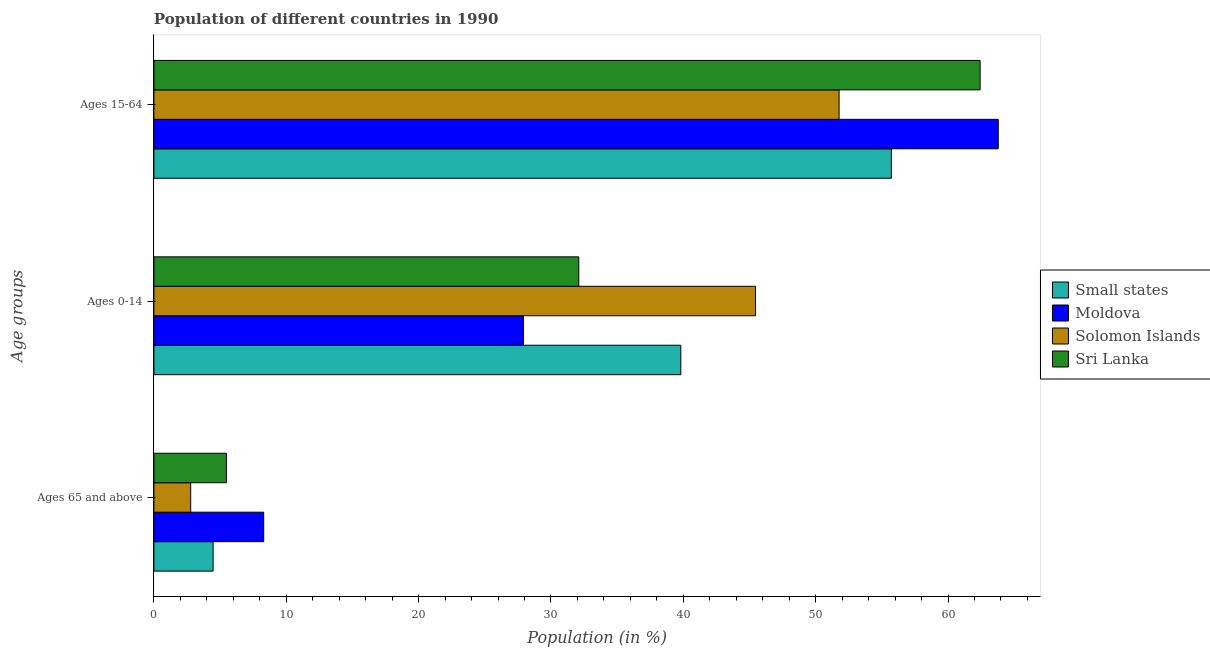What is the label of the 1st group of bars from the top?
Ensure brevity in your answer.  Ages 15-64. What is the percentage of population within the age-group of 65 and above in Solomon Islands?
Give a very brief answer. 2.78. Across all countries, what is the maximum percentage of population within the age-group 0-14?
Give a very brief answer. 45.45. Across all countries, what is the minimum percentage of population within the age-group 15-64?
Make the answer very short. 51.77. In which country was the percentage of population within the age-group 15-64 maximum?
Keep it short and to the point. Moldova. In which country was the percentage of population within the age-group of 65 and above minimum?
Provide a short and direct response. Solomon Islands. What is the total percentage of population within the age-group 15-64 in the graph?
Keep it short and to the point. 233.7. What is the difference between the percentage of population within the age-group 0-14 in Sri Lanka and that in Small states?
Offer a terse response. -7.71. What is the difference between the percentage of population within the age-group 0-14 in Solomon Islands and the percentage of population within the age-group of 65 and above in Sri Lanka?
Provide a short and direct response. 39.98. What is the average percentage of population within the age-group 0-14 per country?
Ensure brevity in your answer.  36.32. What is the difference between the percentage of population within the age-group 0-14 and percentage of population within the age-group 15-64 in Solomon Islands?
Your answer should be very brief. -6.31. What is the ratio of the percentage of population within the age-group 15-64 in Moldova to that in Solomon Islands?
Offer a terse response. 1.23. Is the percentage of population within the age-group 0-14 in Sri Lanka less than that in Moldova?
Give a very brief answer. No. What is the difference between the highest and the second highest percentage of population within the age-group of 65 and above?
Your answer should be compact. 2.82. What is the difference between the highest and the lowest percentage of population within the age-group 15-64?
Provide a succinct answer. 12.02. Is the sum of the percentage of population within the age-group of 65 and above in Sri Lanka and Small states greater than the maximum percentage of population within the age-group 15-64 across all countries?
Keep it short and to the point. No. What does the 3rd bar from the top in Ages 65 and above represents?
Provide a short and direct response. Moldova. What does the 2nd bar from the bottom in Ages 65 and above represents?
Provide a short and direct response. Moldova. Is it the case that in every country, the sum of the percentage of population within the age-group of 65 and above and percentage of population within the age-group 0-14 is greater than the percentage of population within the age-group 15-64?
Give a very brief answer. No. What is the difference between two consecutive major ticks on the X-axis?
Provide a succinct answer. 10. Does the graph contain any zero values?
Keep it short and to the point. No. What is the title of the graph?
Give a very brief answer. Population of different countries in 1990. Does "Suriname" appear as one of the legend labels in the graph?
Offer a very short reply. No. What is the label or title of the X-axis?
Keep it short and to the point. Population (in %). What is the label or title of the Y-axis?
Provide a short and direct response. Age groups. What is the Population (in %) of Small states in Ages 65 and above?
Ensure brevity in your answer.  4.47. What is the Population (in %) in Moldova in Ages 65 and above?
Keep it short and to the point. 8.29. What is the Population (in %) in Solomon Islands in Ages 65 and above?
Your response must be concise. 2.78. What is the Population (in %) in Sri Lanka in Ages 65 and above?
Make the answer very short. 5.48. What is the Population (in %) in Small states in Ages 0-14?
Make the answer very short. 39.81. What is the Population (in %) of Moldova in Ages 0-14?
Offer a very short reply. 27.91. What is the Population (in %) in Solomon Islands in Ages 0-14?
Offer a very short reply. 45.45. What is the Population (in %) of Sri Lanka in Ages 0-14?
Offer a very short reply. 32.1. What is the Population (in %) in Small states in Ages 15-64?
Keep it short and to the point. 55.72. What is the Population (in %) in Moldova in Ages 15-64?
Your answer should be very brief. 63.79. What is the Population (in %) of Solomon Islands in Ages 15-64?
Provide a succinct answer. 51.77. What is the Population (in %) in Sri Lanka in Ages 15-64?
Your answer should be compact. 62.42. Across all Age groups, what is the maximum Population (in %) of Small states?
Give a very brief answer. 55.72. Across all Age groups, what is the maximum Population (in %) in Moldova?
Provide a succinct answer. 63.79. Across all Age groups, what is the maximum Population (in %) in Solomon Islands?
Your answer should be compact. 51.77. Across all Age groups, what is the maximum Population (in %) in Sri Lanka?
Provide a short and direct response. 62.42. Across all Age groups, what is the minimum Population (in %) of Small states?
Your answer should be compact. 4.47. Across all Age groups, what is the minimum Population (in %) in Moldova?
Your answer should be very brief. 8.29. Across all Age groups, what is the minimum Population (in %) of Solomon Islands?
Your response must be concise. 2.78. Across all Age groups, what is the minimum Population (in %) of Sri Lanka?
Keep it short and to the point. 5.48. What is the total Population (in %) of Small states in the graph?
Provide a succinct answer. 100. What is the total Population (in %) of Solomon Islands in the graph?
Offer a terse response. 100. What is the difference between the Population (in %) in Small states in Ages 65 and above and that in Ages 0-14?
Your response must be concise. -35.34. What is the difference between the Population (in %) of Moldova in Ages 65 and above and that in Ages 0-14?
Provide a succinct answer. -19.62. What is the difference between the Population (in %) of Solomon Islands in Ages 65 and above and that in Ages 0-14?
Ensure brevity in your answer.  -42.68. What is the difference between the Population (in %) of Sri Lanka in Ages 65 and above and that in Ages 0-14?
Provide a succinct answer. -26.62. What is the difference between the Population (in %) of Small states in Ages 65 and above and that in Ages 15-64?
Your response must be concise. -51.25. What is the difference between the Population (in %) in Moldova in Ages 65 and above and that in Ages 15-64?
Provide a short and direct response. -55.5. What is the difference between the Population (in %) in Solomon Islands in Ages 65 and above and that in Ages 15-64?
Your response must be concise. -48.99. What is the difference between the Population (in %) of Sri Lanka in Ages 65 and above and that in Ages 15-64?
Provide a short and direct response. -56.95. What is the difference between the Population (in %) of Small states in Ages 0-14 and that in Ages 15-64?
Offer a terse response. -15.91. What is the difference between the Population (in %) in Moldova in Ages 0-14 and that in Ages 15-64?
Provide a succinct answer. -35.88. What is the difference between the Population (in %) in Solomon Islands in Ages 0-14 and that in Ages 15-64?
Give a very brief answer. -6.31. What is the difference between the Population (in %) of Sri Lanka in Ages 0-14 and that in Ages 15-64?
Offer a terse response. -30.32. What is the difference between the Population (in %) of Small states in Ages 65 and above and the Population (in %) of Moldova in Ages 0-14?
Make the answer very short. -23.44. What is the difference between the Population (in %) in Small states in Ages 65 and above and the Population (in %) in Solomon Islands in Ages 0-14?
Offer a very short reply. -40.98. What is the difference between the Population (in %) in Small states in Ages 65 and above and the Population (in %) in Sri Lanka in Ages 0-14?
Provide a succinct answer. -27.63. What is the difference between the Population (in %) of Moldova in Ages 65 and above and the Population (in %) of Solomon Islands in Ages 0-14?
Give a very brief answer. -37.16. What is the difference between the Population (in %) of Moldova in Ages 65 and above and the Population (in %) of Sri Lanka in Ages 0-14?
Your response must be concise. -23.81. What is the difference between the Population (in %) of Solomon Islands in Ages 65 and above and the Population (in %) of Sri Lanka in Ages 0-14?
Provide a succinct answer. -29.32. What is the difference between the Population (in %) of Small states in Ages 65 and above and the Population (in %) of Moldova in Ages 15-64?
Your response must be concise. -59.32. What is the difference between the Population (in %) of Small states in Ages 65 and above and the Population (in %) of Solomon Islands in Ages 15-64?
Offer a very short reply. -47.3. What is the difference between the Population (in %) in Small states in Ages 65 and above and the Population (in %) in Sri Lanka in Ages 15-64?
Your answer should be very brief. -57.95. What is the difference between the Population (in %) of Moldova in Ages 65 and above and the Population (in %) of Solomon Islands in Ages 15-64?
Keep it short and to the point. -43.48. What is the difference between the Population (in %) in Moldova in Ages 65 and above and the Population (in %) in Sri Lanka in Ages 15-64?
Offer a terse response. -54.13. What is the difference between the Population (in %) in Solomon Islands in Ages 65 and above and the Population (in %) in Sri Lanka in Ages 15-64?
Offer a terse response. -59.65. What is the difference between the Population (in %) in Small states in Ages 0-14 and the Population (in %) in Moldova in Ages 15-64?
Provide a succinct answer. -23.98. What is the difference between the Population (in %) in Small states in Ages 0-14 and the Population (in %) in Solomon Islands in Ages 15-64?
Provide a succinct answer. -11.96. What is the difference between the Population (in %) in Small states in Ages 0-14 and the Population (in %) in Sri Lanka in Ages 15-64?
Your response must be concise. -22.61. What is the difference between the Population (in %) of Moldova in Ages 0-14 and the Population (in %) of Solomon Islands in Ages 15-64?
Give a very brief answer. -23.85. What is the difference between the Population (in %) of Moldova in Ages 0-14 and the Population (in %) of Sri Lanka in Ages 15-64?
Your answer should be compact. -34.51. What is the difference between the Population (in %) of Solomon Islands in Ages 0-14 and the Population (in %) of Sri Lanka in Ages 15-64?
Offer a terse response. -16.97. What is the average Population (in %) of Small states per Age groups?
Your response must be concise. 33.33. What is the average Population (in %) in Moldova per Age groups?
Your answer should be very brief. 33.33. What is the average Population (in %) in Solomon Islands per Age groups?
Your answer should be very brief. 33.33. What is the average Population (in %) of Sri Lanka per Age groups?
Your response must be concise. 33.33. What is the difference between the Population (in %) in Small states and Population (in %) in Moldova in Ages 65 and above?
Provide a short and direct response. -3.82. What is the difference between the Population (in %) of Small states and Population (in %) of Solomon Islands in Ages 65 and above?
Provide a short and direct response. 1.7. What is the difference between the Population (in %) of Small states and Population (in %) of Sri Lanka in Ages 65 and above?
Your answer should be very brief. -1. What is the difference between the Population (in %) of Moldova and Population (in %) of Solomon Islands in Ages 65 and above?
Give a very brief answer. 5.52. What is the difference between the Population (in %) in Moldova and Population (in %) in Sri Lanka in Ages 65 and above?
Provide a short and direct response. 2.82. What is the difference between the Population (in %) in Solomon Islands and Population (in %) in Sri Lanka in Ages 65 and above?
Your answer should be very brief. -2.7. What is the difference between the Population (in %) in Small states and Population (in %) in Moldova in Ages 0-14?
Give a very brief answer. 11.89. What is the difference between the Population (in %) of Small states and Population (in %) of Solomon Islands in Ages 0-14?
Provide a short and direct response. -5.65. What is the difference between the Population (in %) in Small states and Population (in %) in Sri Lanka in Ages 0-14?
Make the answer very short. 7.71. What is the difference between the Population (in %) in Moldova and Population (in %) in Solomon Islands in Ages 0-14?
Your response must be concise. -17.54. What is the difference between the Population (in %) of Moldova and Population (in %) of Sri Lanka in Ages 0-14?
Provide a succinct answer. -4.18. What is the difference between the Population (in %) of Solomon Islands and Population (in %) of Sri Lanka in Ages 0-14?
Provide a short and direct response. 13.35. What is the difference between the Population (in %) of Small states and Population (in %) of Moldova in Ages 15-64?
Offer a terse response. -8.07. What is the difference between the Population (in %) of Small states and Population (in %) of Solomon Islands in Ages 15-64?
Offer a very short reply. 3.95. What is the difference between the Population (in %) of Small states and Population (in %) of Sri Lanka in Ages 15-64?
Your response must be concise. -6.7. What is the difference between the Population (in %) in Moldova and Population (in %) in Solomon Islands in Ages 15-64?
Keep it short and to the point. 12.02. What is the difference between the Population (in %) in Moldova and Population (in %) in Sri Lanka in Ages 15-64?
Ensure brevity in your answer.  1.37. What is the difference between the Population (in %) of Solomon Islands and Population (in %) of Sri Lanka in Ages 15-64?
Your answer should be compact. -10.65. What is the ratio of the Population (in %) in Small states in Ages 65 and above to that in Ages 0-14?
Offer a very short reply. 0.11. What is the ratio of the Population (in %) of Moldova in Ages 65 and above to that in Ages 0-14?
Give a very brief answer. 0.3. What is the ratio of the Population (in %) in Solomon Islands in Ages 65 and above to that in Ages 0-14?
Your response must be concise. 0.06. What is the ratio of the Population (in %) in Sri Lanka in Ages 65 and above to that in Ages 0-14?
Provide a short and direct response. 0.17. What is the ratio of the Population (in %) of Small states in Ages 65 and above to that in Ages 15-64?
Provide a succinct answer. 0.08. What is the ratio of the Population (in %) of Moldova in Ages 65 and above to that in Ages 15-64?
Give a very brief answer. 0.13. What is the ratio of the Population (in %) in Solomon Islands in Ages 65 and above to that in Ages 15-64?
Your answer should be very brief. 0.05. What is the ratio of the Population (in %) of Sri Lanka in Ages 65 and above to that in Ages 15-64?
Ensure brevity in your answer.  0.09. What is the ratio of the Population (in %) in Small states in Ages 0-14 to that in Ages 15-64?
Ensure brevity in your answer.  0.71. What is the ratio of the Population (in %) of Moldova in Ages 0-14 to that in Ages 15-64?
Offer a very short reply. 0.44. What is the ratio of the Population (in %) of Solomon Islands in Ages 0-14 to that in Ages 15-64?
Give a very brief answer. 0.88. What is the ratio of the Population (in %) in Sri Lanka in Ages 0-14 to that in Ages 15-64?
Ensure brevity in your answer.  0.51. What is the difference between the highest and the second highest Population (in %) in Small states?
Your response must be concise. 15.91. What is the difference between the highest and the second highest Population (in %) in Moldova?
Give a very brief answer. 35.88. What is the difference between the highest and the second highest Population (in %) of Solomon Islands?
Your answer should be very brief. 6.31. What is the difference between the highest and the second highest Population (in %) in Sri Lanka?
Make the answer very short. 30.32. What is the difference between the highest and the lowest Population (in %) in Small states?
Offer a terse response. 51.25. What is the difference between the highest and the lowest Population (in %) in Moldova?
Your response must be concise. 55.5. What is the difference between the highest and the lowest Population (in %) in Solomon Islands?
Offer a terse response. 48.99. What is the difference between the highest and the lowest Population (in %) of Sri Lanka?
Ensure brevity in your answer.  56.95. 